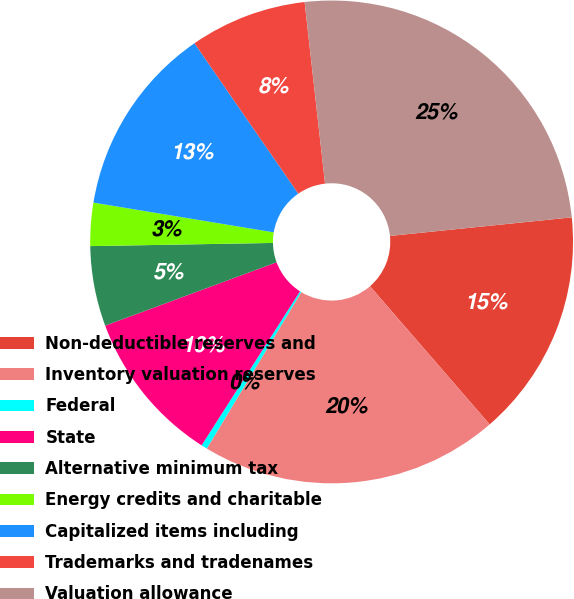<chart> <loc_0><loc_0><loc_500><loc_500><pie_chart><fcel>Non-deductible reserves and<fcel>Inventory valuation reserves<fcel>Federal<fcel>State<fcel>Alternative minimum tax<fcel>Energy credits and charitable<fcel>Capitalized items including<fcel>Trademarks and tradenames<fcel>Valuation allowance<nl><fcel>15.26%<fcel>20.01%<fcel>0.4%<fcel>10.31%<fcel>5.36%<fcel>2.88%<fcel>12.78%<fcel>7.83%<fcel>25.16%<nl></chart> 